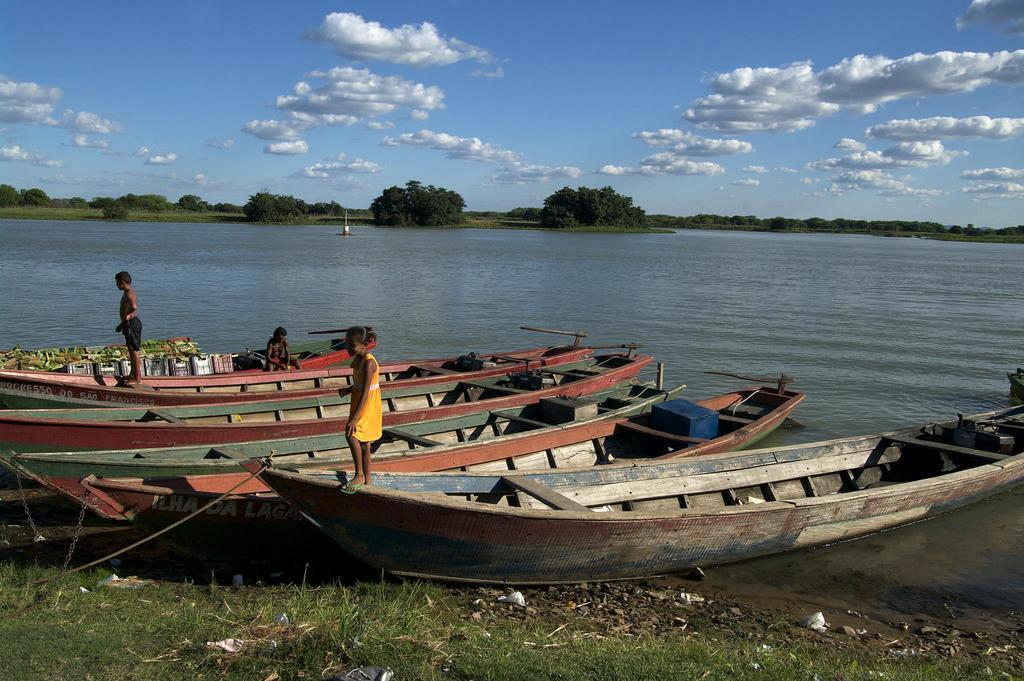Describe this image in one or two sentences. In this image I can see boats on water. On the boats I can see some people. In the background I can see trees and the sky. Here I can see the grass. 